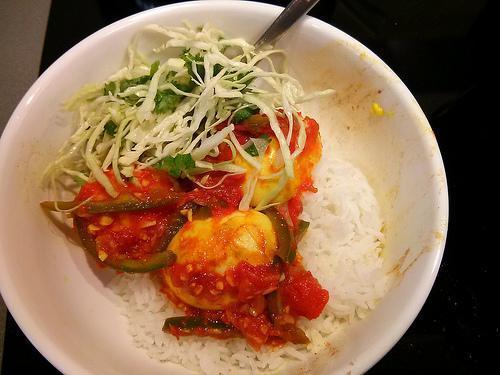How many pieces of tomatoes are there in this plate?
Give a very brief answer. 3. 